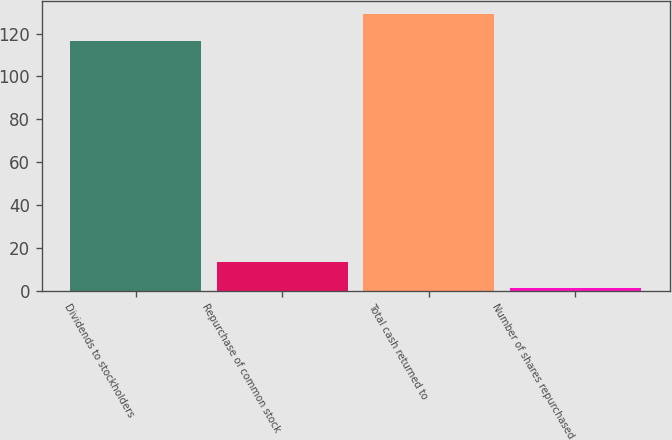<chart> <loc_0><loc_0><loc_500><loc_500><bar_chart><fcel>Dividends to stockholders<fcel>Repurchase of common stock<fcel>Total cash returned to<fcel>Number of shares repurchased<nl><fcel>116.7<fcel>13.21<fcel>128.91<fcel>1<nl></chart> 